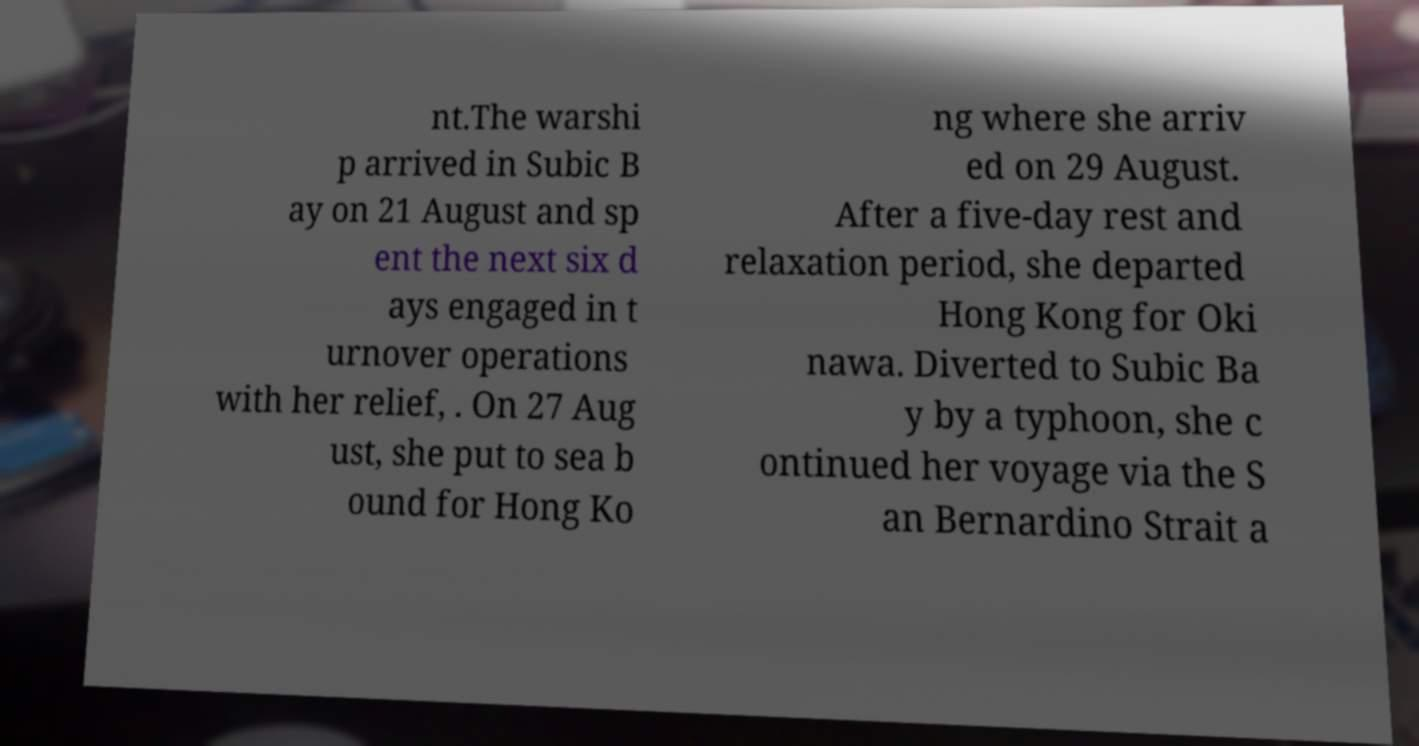Can you read and provide the text displayed in the image?This photo seems to have some interesting text. Can you extract and type it out for me? nt.The warshi p arrived in Subic B ay on 21 August and sp ent the next six d ays engaged in t urnover operations with her relief, . On 27 Aug ust, she put to sea b ound for Hong Ko ng where she arriv ed on 29 August. After a five-day rest and relaxation period, she departed Hong Kong for Oki nawa. Diverted to Subic Ba y by a typhoon, she c ontinued her voyage via the S an Bernardino Strait a 